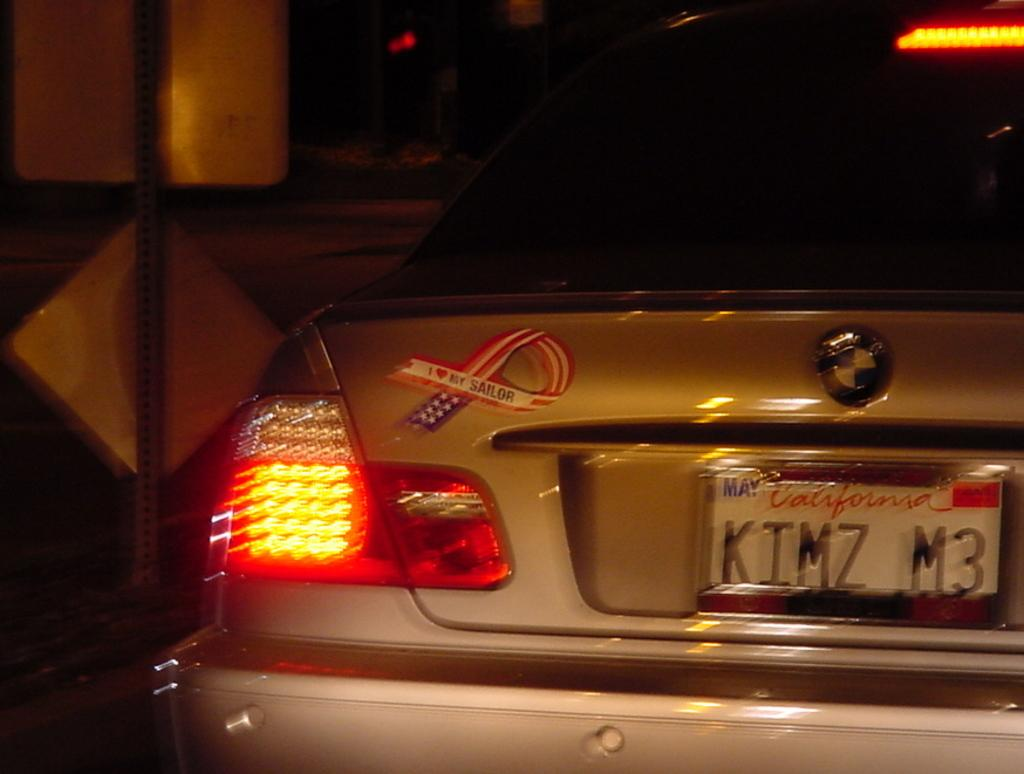<image>
Render a clear and concise summary of the photo. a license plate that is from the state of California 